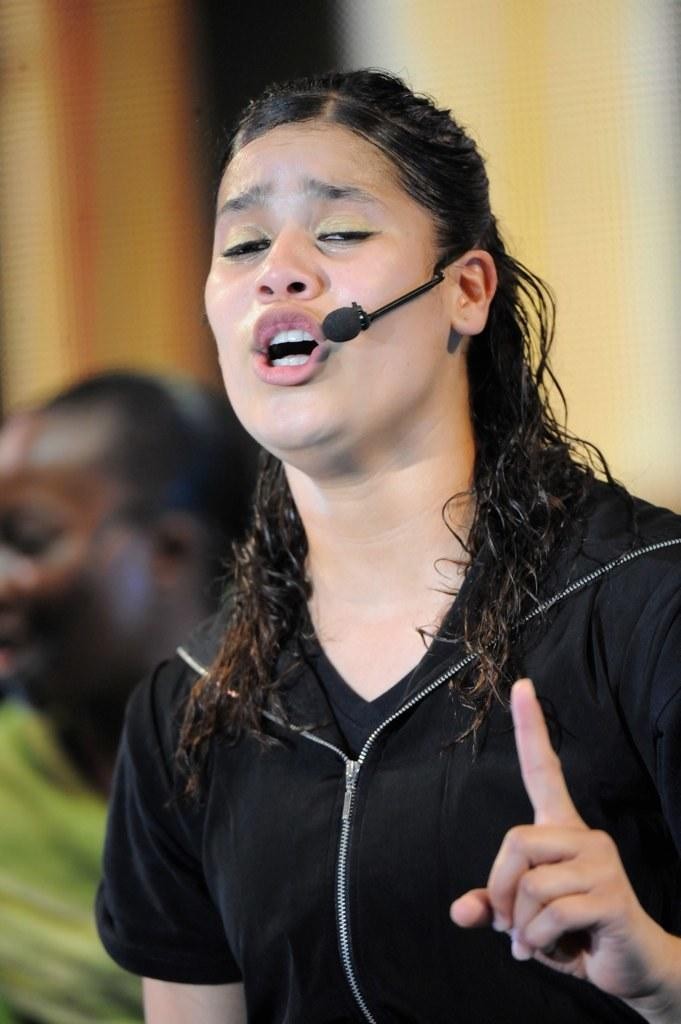What is the woman in the image holding? The woman in the image is holding a mic. Can you describe the setting of the image? There is another person in the background of the image, and the background appears blurry. How many icicles are hanging from the woman's mic in the image? There are no icicles present in the image. What type of ducks can be seen swimming in the background of the image? There are no ducks present in the image. 